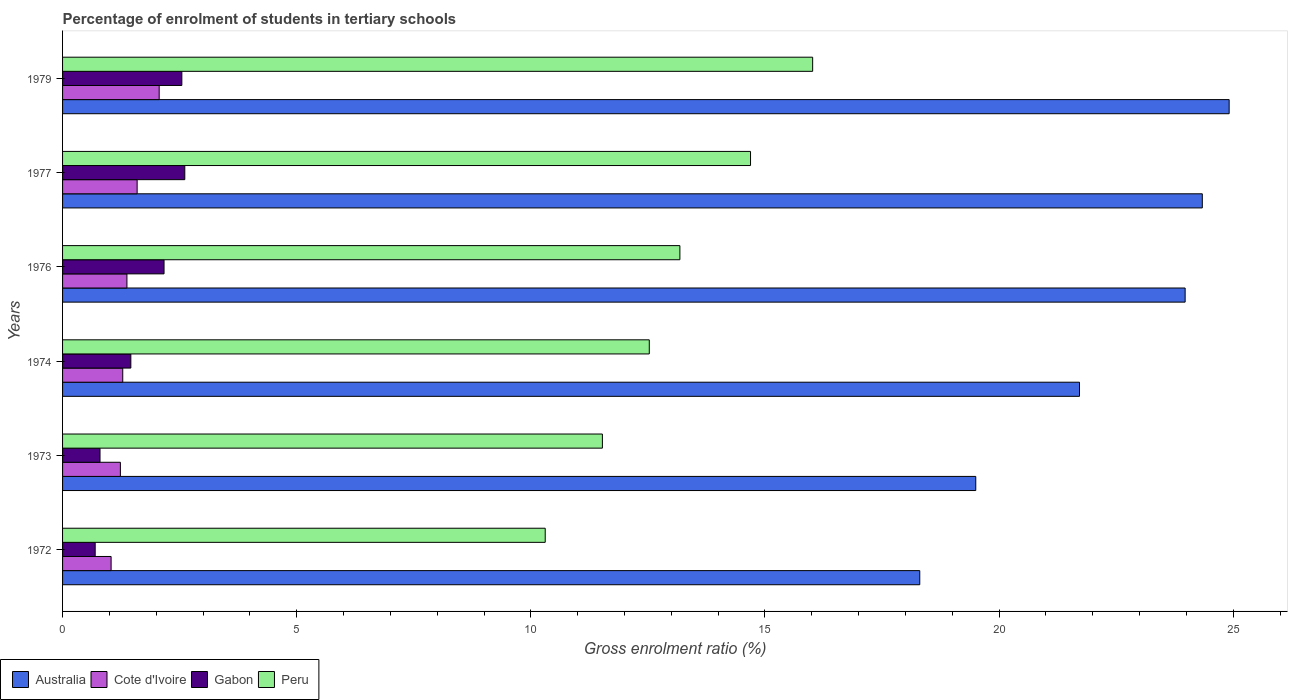How many different coloured bars are there?
Your answer should be very brief. 4. How many groups of bars are there?
Make the answer very short. 6. How many bars are there on the 6th tick from the bottom?
Your answer should be very brief. 4. What is the label of the 3rd group of bars from the top?
Your answer should be compact. 1976. What is the percentage of students enrolled in tertiary schools in Peru in 1972?
Offer a terse response. 10.31. Across all years, what is the maximum percentage of students enrolled in tertiary schools in Cote d'Ivoire?
Give a very brief answer. 2.06. Across all years, what is the minimum percentage of students enrolled in tertiary schools in Cote d'Ivoire?
Make the answer very short. 1.04. In which year was the percentage of students enrolled in tertiary schools in Cote d'Ivoire maximum?
Provide a short and direct response. 1979. What is the total percentage of students enrolled in tertiary schools in Cote d'Ivoire in the graph?
Provide a succinct answer. 8.59. What is the difference between the percentage of students enrolled in tertiary schools in Peru in 1974 and that in 1979?
Provide a succinct answer. -3.49. What is the difference between the percentage of students enrolled in tertiary schools in Australia in 1979 and the percentage of students enrolled in tertiary schools in Cote d'Ivoire in 1974?
Make the answer very short. 23.63. What is the average percentage of students enrolled in tertiary schools in Peru per year?
Your response must be concise. 13.04. In the year 1977, what is the difference between the percentage of students enrolled in tertiary schools in Australia and percentage of students enrolled in tertiary schools in Cote d'Ivoire?
Give a very brief answer. 22.75. In how many years, is the percentage of students enrolled in tertiary schools in Peru greater than 13 %?
Offer a terse response. 3. What is the ratio of the percentage of students enrolled in tertiary schools in Peru in 1973 to that in 1979?
Your answer should be compact. 0.72. What is the difference between the highest and the second highest percentage of students enrolled in tertiary schools in Peru?
Offer a terse response. 1.33. What is the difference between the highest and the lowest percentage of students enrolled in tertiary schools in Cote d'Ivoire?
Give a very brief answer. 1.03. In how many years, is the percentage of students enrolled in tertiary schools in Cote d'Ivoire greater than the average percentage of students enrolled in tertiary schools in Cote d'Ivoire taken over all years?
Your answer should be compact. 2. Is it the case that in every year, the sum of the percentage of students enrolled in tertiary schools in Cote d'Ivoire and percentage of students enrolled in tertiary schools in Australia is greater than the sum of percentage of students enrolled in tertiary schools in Gabon and percentage of students enrolled in tertiary schools in Peru?
Keep it short and to the point. Yes. What does the 2nd bar from the bottom in 1974 represents?
Your answer should be compact. Cote d'Ivoire. Is it the case that in every year, the sum of the percentage of students enrolled in tertiary schools in Australia and percentage of students enrolled in tertiary schools in Gabon is greater than the percentage of students enrolled in tertiary schools in Peru?
Your answer should be compact. Yes. How many bars are there?
Provide a succinct answer. 24. Are the values on the major ticks of X-axis written in scientific E-notation?
Provide a succinct answer. No. Does the graph contain any zero values?
Provide a short and direct response. No. Does the graph contain grids?
Your answer should be compact. No. How many legend labels are there?
Make the answer very short. 4. How are the legend labels stacked?
Your answer should be compact. Horizontal. What is the title of the graph?
Offer a very short reply. Percentage of enrolment of students in tertiary schools. What is the Gross enrolment ratio (%) in Australia in 1972?
Give a very brief answer. 18.31. What is the Gross enrolment ratio (%) in Cote d'Ivoire in 1972?
Make the answer very short. 1.04. What is the Gross enrolment ratio (%) of Gabon in 1972?
Offer a terse response. 0.7. What is the Gross enrolment ratio (%) in Peru in 1972?
Your answer should be very brief. 10.31. What is the Gross enrolment ratio (%) in Australia in 1973?
Give a very brief answer. 19.5. What is the Gross enrolment ratio (%) in Cote d'Ivoire in 1973?
Offer a very short reply. 1.23. What is the Gross enrolment ratio (%) of Gabon in 1973?
Make the answer very short. 0.8. What is the Gross enrolment ratio (%) of Peru in 1973?
Your response must be concise. 11.53. What is the Gross enrolment ratio (%) of Australia in 1974?
Ensure brevity in your answer.  21.72. What is the Gross enrolment ratio (%) of Cote d'Ivoire in 1974?
Offer a terse response. 1.29. What is the Gross enrolment ratio (%) of Gabon in 1974?
Ensure brevity in your answer.  1.46. What is the Gross enrolment ratio (%) in Peru in 1974?
Ensure brevity in your answer.  12.53. What is the Gross enrolment ratio (%) of Australia in 1976?
Offer a very short reply. 23.97. What is the Gross enrolment ratio (%) in Cote d'Ivoire in 1976?
Offer a very short reply. 1.37. What is the Gross enrolment ratio (%) in Gabon in 1976?
Your response must be concise. 2.17. What is the Gross enrolment ratio (%) in Peru in 1976?
Your answer should be very brief. 13.18. What is the Gross enrolment ratio (%) of Australia in 1977?
Provide a short and direct response. 24.34. What is the Gross enrolment ratio (%) in Cote d'Ivoire in 1977?
Keep it short and to the point. 1.59. What is the Gross enrolment ratio (%) in Gabon in 1977?
Provide a short and direct response. 2.61. What is the Gross enrolment ratio (%) of Peru in 1977?
Your response must be concise. 14.69. What is the Gross enrolment ratio (%) of Australia in 1979?
Keep it short and to the point. 24.91. What is the Gross enrolment ratio (%) in Cote d'Ivoire in 1979?
Provide a succinct answer. 2.06. What is the Gross enrolment ratio (%) in Gabon in 1979?
Provide a short and direct response. 2.55. What is the Gross enrolment ratio (%) of Peru in 1979?
Offer a terse response. 16.02. Across all years, what is the maximum Gross enrolment ratio (%) in Australia?
Provide a short and direct response. 24.91. Across all years, what is the maximum Gross enrolment ratio (%) of Cote d'Ivoire?
Your answer should be very brief. 2.06. Across all years, what is the maximum Gross enrolment ratio (%) of Gabon?
Provide a short and direct response. 2.61. Across all years, what is the maximum Gross enrolment ratio (%) of Peru?
Make the answer very short. 16.02. Across all years, what is the minimum Gross enrolment ratio (%) in Australia?
Your answer should be compact. 18.31. Across all years, what is the minimum Gross enrolment ratio (%) in Cote d'Ivoire?
Give a very brief answer. 1.04. Across all years, what is the minimum Gross enrolment ratio (%) of Gabon?
Your answer should be very brief. 0.7. Across all years, what is the minimum Gross enrolment ratio (%) in Peru?
Ensure brevity in your answer.  10.31. What is the total Gross enrolment ratio (%) of Australia in the graph?
Offer a terse response. 132.75. What is the total Gross enrolment ratio (%) in Cote d'Ivoire in the graph?
Keep it short and to the point. 8.59. What is the total Gross enrolment ratio (%) in Gabon in the graph?
Offer a terse response. 10.28. What is the total Gross enrolment ratio (%) in Peru in the graph?
Ensure brevity in your answer.  78.26. What is the difference between the Gross enrolment ratio (%) of Australia in 1972 and that in 1973?
Your response must be concise. -1.2. What is the difference between the Gross enrolment ratio (%) in Cote d'Ivoire in 1972 and that in 1973?
Ensure brevity in your answer.  -0.2. What is the difference between the Gross enrolment ratio (%) in Gabon in 1972 and that in 1973?
Your response must be concise. -0.1. What is the difference between the Gross enrolment ratio (%) in Peru in 1972 and that in 1973?
Keep it short and to the point. -1.22. What is the difference between the Gross enrolment ratio (%) in Australia in 1972 and that in 1974?
Provide a succinct answer. -3.41. What is the difference between the Gross enrolment ratio (%) in Cote d'Ivoire in 1972 and that in 1974?
Give a very brief answer. -0.25. What is the difference between the Gross enrolment ratio (%) of Gabon in 1972 and that in 1974?
Your response must be concise. -0.76. What is the difference between the Gross enrolment ratio (%) of Peru in 1972 and that in 1974?
Offer a terse response. -2.22. What is the difference between the Gross enrolment ratio (%) in Australia in 1972 and that in 1976?
Give a very brief answer. -5.67. What is the difference between the Gross enrolment ratio (%) of Cote d'Ivoire in 1972 and that in 1976?
Your response must be concise. -0.34. What is the difference between the Gross enrolment ratio (%) of Gabon in 1972 and that in 1976?
Your response must be concise. -1.47. What is the difference between the Gross enrolment ratio (%) in Peru in 1972 and that in 1976?
Your response must be concise. -2.88. What is the difference between the Gross enrolment ratio (%) of Australia in 1972 and that in 1977?
Your answer should be very brief. -6.03. What is the difference between the Gross enrolment ratio (%) in Cote d'Ivoire in 1972 and that in 1977?
Offer a very short reply. -0.56. What is the difference between the Gross enrolment ratio (%) of Gabon in 1972 and that in 1977?
Your answer should be very brief. -1.91. What is the difference between the Gross enrolment ratio (%) of Peru in 1972 and that in 1977?
Offer a very short reply. -4.38. What is the difference between the Gross enrolment ratio (%) of Australia in 1972 and that in 1979?
Keep it short and to the point. -6.61. What is the difference between the Gross enrolment ratio (%) of Cote d'Ivoire in 1972 and that in 1979?
Provide a short and direct response. -1.03. What is the difference between the Gross enrolment ratio (%) of Gabon in 1972 and that in 1979?
Offer a very short reply. -1.85. What is the difference between the Gross enrolment ratio (%) in Peru in 1972 and that in 1979?
Your response must be concise. -5.71. What is the difference between the Gross enrolment ratio (%) in Australia in 1973 and that in 1974?
Your answer should be very brief. -2.22. What is the difference between the Gross enrolment ratio (%) in Cote d'Ivoire in 1973 and that in 1974?
Your response must be concise. -0.05. What is the difference between the Gross enrolment ratio (%) in Gabon in 1973 and that in 1974?
Make the answer very short. -0.66. What is the difference between the Gross enrolment ratio (%) of Peru in 1973 and that in 1974?
Offer a terse response. -1. What is the difference between the Gross enrolment ratio (%) in Australia in 1973 and that in 1976?
Keep it short and to the point. -4.47. What is the difference between the Gross enrolment ratio (%) of Cote d'Ivoire in 1973 and that in 1976?
Give a very brief answer. -0.14. What is the difference between the Gross enrolment ratio (%) of Gabon in 1973 and that in 1976?
Your answer should be compact. -1.37. What is the difference between the Gross enrolment ratio (%) of Peru in 1973 and that in 1976?
Ensure brevity in your answer.  -1.66. What is the difference between the Gross enrolment ratio (%) of Australia in 1973 and that in 1977?
Your answer should be very brief. -4.84. What is the difference between the Gross enrolment ratio (%) in Cote d'Ivoire in 1973 and that in 1977?
Your answer should be very brief. -0.36. What is the difference between the Gross enrolment ratio (%) of Gabon in 1973 and that in 1977?
Your answer should be very brief. -1.81. What is the difference between the Gross enrolment ratio (%) in Peru in 1973 and that in 1977?
Offer a terse response. -3.16. What is the difference between the Gross enrolment ratio (%) of Australia in 1973 and that in 1979?
Your response must be concise. -5.41. What is the difference between the Gross enrolment ratio (%) in Cote d'Ivoire in 1973 and that in 1979?
Ensure brevity in your answer.  -0.83. What is the difference between the Gross enrolment ratio (%) of Gabon in 1973 and that in 1979?
Your answer should be compact. -1.75. What is the difference between the Gross enrolment ratio (%) of Peru in 1973 and that in 1979?
Keep it short and to the point. -4.49. What is the difference between the Gross enrolment ratio (%) in Australia in 1974 and that in 1976?
Provide a short and direct response. -2.26. What is the difference between the Gross enrolment ratio (%) in Cote d'Ivoire in 1974 and that in 1976?
Ensure brevity in your answer.  -0.09. What is the difference between the Gross enrolment ratio (%) in Gabon in 1974 and that in 1976?
Your answer should be very brief. -0.71. What is the difference between the Gross enrolment ratio (%) of Peru in 1974 and that in 1976?
Make the answer very short. -0.65. What is the difference between the Gross enrolment ratio (%) in Australia in 1974 and that in 1977?
Provide a short and direct response. -2.62. What is the difference between the Gross enrolment ratio (%) of Cote d'Ivoire in 1974 and that in 1977?
Your response must be concise. -0.31. What is the difference between the Gross enrolment ratio (%) of Gabon in 1974 and that in 1977?
Ensure brevity in your answer.  -1.15. What is the difference between the Gross enrolment ratio (%) in Peru in 1974 and that in 1977?
Your answer should be compact. -2.16. What is the difference between the Gross enrolment ratio (%) in Australia in 1974 and that in 1979?
Your response must be concise. -3.2. What is the difference between the Gross enrolment ratio (%) of Cote d'Ivoire in 1974 and that in 1979?
Provide a short and direct response. -0.78. What is the difference between the Gross enrolment ratio (%) of Gabon in 1974 and that in 1979?
Ensure brevity in your answer.  -1.09. What is the difference between the Gross enrolment ratio (%) in Peru in 1974 and that in 1979?
Offer a very short reply. -3.49. What is the difference between the Gross enrolment ratio (%) in Australia in 1976 and that in 1977?
Provide a short and direct response. -0.37. What is the difference between the Gross enrolment ratio (%) in Cote d'Ivoire in 1976 and that in 1977?
Your answer should be very brief. -0.22. What is the difference between the Gross enrolment ratio (%) of Gabon in 1976 and that in 1977?
Keep it short and to the point. -0.44. What is the difference between the Gross enrolment ratio (%) in Peru in 1976 and that in 1977?
Offer a terse response. -1.51. What is the difference between the Gross enrolment ratio (%) of Australia in 1976 and that in 1979?
Provide a short and direct response. -0.94. What is the difference between the Gross enrolment ratio (%) in Cote d'Ivoire in 1976 and that in 1979?
Offer a terse response. -0.69. What is the difference between the Gross enrolment ratio (%) of Gabon in 1976 and that in 1979?
Your answer should be very brief. -0.38. What is the difference between the Gross enrolment ratio (%) in Peru in 1976 and that in 1979?
Your response must be concise. -2.84. What is the difference between the Gross enrolment ratio (%) in Australia in 1977 and that in 1979?
Your answer should be compact. -0.57. What is the difference between the Gross enrolment ratio (%) of Cote d'Ivoire in 1977 and that in 1979?
Your answer should be compact. -0.47. What is the difference between the Gross enrolment ratio (%) in Gabon in 1977 and that in 1979?
Offer a very short reply. 0.06. What is the difference between the Gross enrolment ratio (%) of Peru in 1977 and that in 1979?
Provide a succinct answer. -1.33. What is the difference between the Gross enrolment ratio (%) of Australia in 1972 and the Gross enrolment ratio (%) of Cote d'Ivoire in 1973?
Provide a succinct answer. 17.07. What is the difference between the Gross enrolment ratio (%) of Australia in 1972 and the Gross enrolment ratio (%) of Gabon in 1973?
Make the answer very short. 17.51. What is the difference between the Gross enrolment ratio (%) of Australia in 1972 and the Gross enrolment ratio (%) of Peru in 1973?
Your answer should be very brief. 6.78. What is the difference between the Gross enrolment ratio (%) of Cote d'Ivoire in 1972 and the Gross enrolment ratio (%) of Gabon in 1973?
Offer a terse response. 0.24. What is the difference between the Gross enrolment ratio (%) in Cote d'Ivoire in 1972 and the Gross enrolment ratio (%) in Peru in 1973?
Your response must be concise. -10.49. What is the difference between the Gross enrolment ratio (%) of Gabon in 1972 and the Gross enrolment ratio (%) of Peru in 1973?
Provide a short and direct response. -10.83. What is the difference between the Gross enrolment ratio (%) in Australia in 1972 and the Gross enrolment ratio (%) in Cote d'Ivoire in 1974?
Provide a succinct answer. 17.02. What is the difference between the Gross enrolment ratio (%) of Australia in 1972 and the Gross enrolment ratio (%) of Gabon in 1974?
Make the answer very short. 16.85. What is the difference between the Gross enrolment ratio (%) of Australia in 1972 and the Gross enrolment ratio (%) of Peru in 1974?
Offer a terse response. 5.78. What is the difference between the Gross enrolment ratio (%) of Cote d'Ivoire in 1972 and the Gross enrolment ratio (%) of Gabon in 1974?
Provide a short and direct response. -0.42. What is the difference between the Gross enrolment ratio (%) in Cote d'Ivoire in 1972 and the Gross enrolment ratio (%) in Peru in 1974?
Offer a terse response. -11.49. What is the difference between the Gross enrolment ratio (%) of Gabon in 1972 and the Gross enrolment ratio (%) of Peru in 1974?
Your answer should be very brief. -11.83. What is the difference between the Gross enrolment ratio (%) of Australia in 1972 and the Gross enrolment ratio (%) of Cote d'Ivoire in 1976?
Give a very brief answer. 16.93. What is the difference between the Gross enrolment ratio (%) in Australia in 1972 and the Gross enrolment ratio (%) in Gabon in 1976?
Offer a terse response. 16.14. What is the difference between the Gross enrolment ratio (%) in Australia in 1972 and the Gross enrolment ratio (%) in Peru in 1976?
Provide a short and direct response. 5.12. What is the difference between the Gross enrolment ratio (%) in Cote d'Ivoire in 1972 and the Gross enrolment ratio (%) in Gabon in 1976?
Offer a terse response. -1.13. What is the difference between the Gross enrolment ratio (%) in Cote d'Ivoire in 1972 and the Gross enrolment ratio (%) in Peru in 1976?
Your answer should be compact. -12.15. What is the difference between the Gross enrolment ratio (%) in Gabon in 1972 and the Gross enrolment ratio (%) in Peru in 1976?
Ensure brevity in your answer.  -12.49. What is the difference between the Gross enrolment ratio (%) of Australia in 1972 and the Gross enrolment ratio (%) of Cote d'Ivoire in 1977?
Provide a succinct answer. 16.71. What is the difference between the Gross enrolment ratio (%) in Australia in 1972 and the Gross enrolment ratio (%) in Gabon in 1977?
Your answer should be compact. 15.7. What is the difference between the Gross enrolment ratio (%) in Australia in 1972 and the Gross enrolment ratio (%) in Peru in 1977?
Offer a terse response. 3.61. What is the difference between the Gross enrolment ratio (%) of Cote d'Ivoire in 1972 and the Gross enrolment ratio (%) of Gabon in 1977?
Offer a terse response. -1.57. What is the difference between the Gross enrolment ratio (%) of Cote d'Ivoire in 1972 and the Gross enrolment ratio (%) of Peru in 1977?
Provide a short and direct response. -13.66. What is the difference between the Gross enrolment ratio (%) in Gabon in 1972 and the Gross enrolment ratio (%) in Peru in 1977?
Your answer should be compact. -14. What is the difference between the Gross enrolment ratio (%) of Australia in 1972 and the Gross enrolment ratio (%) of Cote d'Ivoire in 1979?
Make the answer very short. 16.24. What is the difference between the Gross enrolment ratio (%) of Australia in 1972 and the Gross enrolment ratio (%) of Gabon in 1979?
Your answer should be very brief. 15.76. What is the difference between the Gross enrolment ratio (%) of Australia in 1972 and the Gross enrolment ratio (%) of Peru in 1979?
Offer a very short reply. 2.29. What is the difference between the Gross enrolment ratio (%) of Cote d'Ivoire in 1972 and the Gross enrolment ratio (%) of Gabon in 1979?
Ensure brevity in your answer.  -1.51. What is the difference between the Gross enrolment ratio (%) in Cote d'Ivoire in 1972 and the Gross enrolment ratio (%) in Peru in 1979?
Offer a very short reply. -14.98. What is the difference between the Gross enrolment ratio (%) in Gabon in 1972 and the Gross enrolment ratio (%) in Peru in 1979?
Ensure brevity in your answer.  -15.32. What is the difference between the Gross enrolment ratio (%) in Australia in 1973 and the Gross enrolment ratio (%) in Cote d'Ivoire in 1974?
Your answer should be very brief. 18.22. What is the difference between the Gross enrolment ratio (%) of Australia in 1973 and the Gross enrolment ratio (%) of Gabon in 1974?
Keep it short and to the point. 18.04. What is the difference between the Gross enrolment ratio (%) in Australia in 1973 and the Gross enrolment ratio (%) in Peru in 1974?
Give a very brief answer. 6.97. What is the difference between the Gross enrolment ratio (%) in Cote d'Ivoire in 1973 and the Gross enrolment ratio (%) in Gabon in 1974?
Offer a very short reply. -0.22. What is the difference between the Gross enrolment ratio (%) of Cote d'Ivoire in 1973 and the Gross enrolment ratio (%) of Peru in 1974?
Provide a short and direct response. -11.29. What is the difference between the Gross enrolment ratio (%) of Gabon in 1973 and the Gross enrolment ratio (%) of Peru in 1974?
Your response must be concise. -11.73. What is the difference between the Gross enrolment ratio (%) of Australia in 1973 and the Gross enrolment ratio (%) of Cote d'Ivoire in 1976?
Your response must be concise. 18.13. What is the difference between the Gross enrolment ratio (%) in Australia in 1973 and the Gross enrolment ratio (%) in Gabon in 1976?
Your answer should be very brief. 17.34. What is the difference between the Gross enrolment ratio (%) of Australia in 1973 and the Gross enrolment ratio (%) of Peru in 1976?
Offer a very short reply. 6.32. What is the difference between the Gross enrolment ratio (%) in Cote d'Ivoire in 1973 and the Gross enrolment ratio (%) in Gabon in 1976?
Your answer should be compact. -0.93. What is the difference between the Gross enrolment ratio (%) of Cote d'Ivoire in 1973 and the Gross enrolment ratio (%) of Peru in 1976?
Provide a short and direct response. -11.95. What is the difference between the Gross enrolment ratio (%) of Gabon in 1973 and the Gross enrolment ratio (%) of Peru in 1976?
Provide a succinct answer. -12.38. What is the difference between the Gross enrolment ratio (%) of Australia in 1973 and the Gross enrolment ratio (%) of Cote d'Ivoire in 1977?
Keep it short and to the point. 17.91. What is the difference between the Gross enrolment ratio (%) of Australia in 1973 and the Gross enrolment ratio (%) of Gabon in 1977?
Ensure brevity in your answer.  16.89. What is the difference between the Gross enrolment ratio (%) of Australia in 1973 and the Gross enrolment ratio (%) of Peru in 1977?
Keep it short and to the point. 4.81. What is the difference between the Gross enrolment ratio (%) of Cote d'Ivoire in 1973 and the Gross enrolment ratio (%) of Gabon in 1977?
Your answer should be compact. -1.38. What is the difference between the Gross enrolment ratio (%) of Cote d'Ivoire in 1973 and the Gross enrolment ratio (%) of Peru in 1977?
Offer a terse response. -13.46. What is the difference between the Gross enrolment ratio (%) of Gabon in 1973 and the Gross enrolment ratio (%) of Peru in 1977?
Give a very brief answer. -13.89. What is the difference between the Gross enrolment ratio (%) of Australia in 1973 and the Gross enrolment ratio (%) of Cote d'Ivoire in 1979?
Give a very brief answer. 17.44. What is the difference between the Gross enrolment ratio (%) of Australia in 1973 and the Gross enrolment ratio (%) of Gabon in 1979?
Provide a short and direct response. 16.95. What is the difference between the Gross enrolment ratio (%) of Australia in 1973 and the Gross enrolment ratio (%) of Peru in 1979?
Your answer should be compact. 3.48. What is the difference between the Gross enrolment ratio (%) in Cote d'Ivoire in 1973 and the Gross enrolment ratio (%) in Gabon in 1979?
Provide a short and direct response. -1.31. What is the difference between the Gross enrolment ratio (%) of Cote d'Ivoire in 1973 and the Gross enrolment ratio (%) of Peru in 1979?
Your answer should be compact. -14.78. What is the difference between the Gross enrolment ratio (%) in Gabon in 1973 and the Gross enrolment ratio (%) in Peru in 1979?
Your response must be concise. -15.22. What is the difference between the Gross enrolment ratio (%) of Australia in 1974 and the Gross enrolment ratio (%) of Cote d'Ivoire in 1976?
Your answer should be compact. 20.34. What is the difference between the Gross enrolment ratio (%) of Australia in 1974 and the Gross enrolment ratio (%) of Gabon in 1976?
Your answer should be compact. 19.55. What is the difference between the Gross enrolment ratio (%) of Australia in 1974 and the Gross enrolment ratio (%) of Peru in 1976?
Make the answer very short. 8.53. What is the difference between the Gross enrolment ratio (%) of Cote d'Ivoire in 1974 and the Gross enrolment ratio (%) of Gabon in 1976?
Ensure brevity in your answer.  -0.88. What is the difference between the Gross enrolment ratio (%) of Cote d'Ivoire in 1974 and the Gross enrolment ratio (%) of Peru in 1976?
Ensure brevity in your answer.  -11.9. What is the difference between the Gross enrolment ratio (%) in Gabon in 1974 and the Gross enrolment ratio (%) in Peru in 1976?
Provide a succinct answer. -11.73. What is the difference between the Gross enrolment ratio (%) in Australia in 1974 and the Gross enrolment ratio (%) in Cote d'Ivoire in 1977?
Ensure brevity in your answer.  20.12. What is the difference between the Gross enrolment ratio (%) in Australia in 1974 and the Gross enrolment ratio (%) in Gabon in 1977?
Your response must be concise. 19.11. What is the difference between the Gross enrolment ratio (%) of Australia in 1974 and the Gross enrolment ratio (%) of Peru in 1977?
Ensure brevity in your answer.  7.03. What is the difference between the Gross enrolment ratio (%) of Cote d'Ivoire in 1974 and the Gross enrolment ratio (%) of Gabon in 1977?
Offer a terse response. -1.33. What is the difference between the Gross enrolment ratio (%) in Cote d'Ivoire in 1974 and the Gross enrolment ratio (%) in Peru in 1977?
Provide a short and direct response. -13.41. What is the difference between the Gross enrolment ratio (%) in Gabon in 1974 and the Gross enrolment ratio (%) in Peru in 1977?
Ensure brevity in your answer.  -13.23. What is the difference between the Gross enrolment ratio (%) of Australia in 1974 and the Gross enrolment ratio (%) of Cote d'Ivoire in 1979?
Offer a very short reply. 19.65. What is the difference between the Gross enrolment ratio (%) in Australia in 1974 and the Gross enrolment ratio (%) in Gabon in 1979?
Ensure brevity in your answer.  19.17. What is the difference between the Gross enrolment ratio (%) in Australia in 1974 and the Gross enrolment ratio (%) in Peru in 1979?
Your response must be concise. 5.7. What is the difference between the Gross enrolment ratio (%) in Cote d'Ivoire in 1974 and the Gross enrolment ratio (%) in Gabon in 1979?
Provide a short and direct response. -1.26. What is the difference between the Gross enrolment ratio (%) of Cote d'Ivoire in 1974 and the Gross enrolment ratio (%) of Peru in 1979?
Provide a succinct answer. -14.73. What is the difference between the Gross enrolment ratio (%) in Gabon in 1974 and the Gross enrolment ratio (%) in Peru in 1979?
Provide a succinct answer. -14.56. What is the difference between the Gross enrolment ratio (%) in Australia in 1976 and the Gross enrolment ratio (%) in Cote d'Ivoire in 1977?
Your answer should be very brief. 22.38. What is the difference between the Gross enrolment ratio (%) in Australia in 1976 and the Gross enrolment ratio (%) in Gabon in 1977?
Give a very brief answer. 21.36. What is the difference between the Gross enrolment ratio (%) in Australia in 1976 and the Gross enrolment ratio (%) in Peru in 1977?
Provide a succinct answer. 9.28. What is the difference between the Gross enrolment ratio (%) of Cote d'Ivoire in 1976 and the Gross enrolment ratio (%) of Gabon in 1977?
Keep it short and to the point. -1.24. What is the difference between the Gross enrolment ratio (%) of Cote d'Ivoire in 1976 and the Gross enrolment ratio (%) of Peru in 1977?
Your response must be concise. -13.32. What is the difference between the Gross enrolment ratio (%) of Gabon in 1976 and the Gross enrolment ratio (%) of Peru in 1977?
Provide a succinct answer. -12.53. What is the difference between the Gross enrolment ratio (%) of Australia in 1976 and the Gross enrolment ratio (%) of Cote d'Ivoire in 1979?
Offer a very short reply. 21.91. What is the difference between the Gross enrolment ratio (%) of Australia in 1976 and the Gross enrolment ratio (%) of Gabon in 1979?
Your answer should be compact. 21.43. What is the difference between the Gross enrolment ratio (%) of Australia in 1976 and the Gross enrolment ratio (%) of Peru in 1979?
Your answer should be compact. 7.95. What is the difference between the Gross enrolment ratio (%) of Cote d'Ivoire in 1976 and the Gross enrolment ratio (%) of Gabon in 1979?
Your answer should be very brief. -1.17. What is the difference between the Gross enrolment ratio (%) of Cote d'Ivoire in 1976 and the Gross enrolment ratio (%) of Peru in 1979?
Ensure brevity in your answer.  -14.64. What is the difference between the Gross enrolment ratio (%) of Gabon in 1976 and the Gross enrolment ratio (%) of Peru in 1979?
Offer a terse response. -13.85. What is the difference between the Gross enrolment ratio (%) in Australia in 1977 and the Gross enrolment ratio (%) in Cote d'Ivoire in 1979?
Provide a short and direct response. 22.28. What is the difference between the Gross enrolment ratio (%) in Australia in 1977 and the Gross enrolment ratio (%) in Gabon in 1979?
Your response must be concise. 21.79. What is the difference between the Gross enrolment ratio (%) in Australia in 1977 and the Gross enrolment ratio (%) in Peru in 1979?
Make the answer very short. 8.32. What is the difference between the Gross enrolment ratio (%) in Cote d'Ivoire in 1977 and the Gross enrolment ratio (%) in Gabon in 1979?
Keep it short and to the point. -0.95. What is the difference between the Gross enrolment ratio (%) in Cote d'Ivoire in 1977 and the Gross enrolment ratio (%) in Peru in 1979?
Ensure brevity in your answer.  -14.43. What is the difference between the Gross enrolment ratio (%) in Gabon in 1977 and the Gross enrolment ratio (%) in Peru in 1979?
Keep it short and to the point. -13.41. What is the average Gross enrolment ratio (%) in Australia per year?
Your response must be concise. 22.13. What is the average Gross enrolment ratio (%) in Cote d'Ivoire per year?
Make the answer very short. 1.43. What is the average Gross enrolment ratio (%) of Gabon per year?
Offer a very short reply. 1.71. What is the average Gross enrolment ratio (%) of Peru per year?
Make the answer very short. 13.04. In the year 1972, what is the difference between the Gross enrolment ratio (%) of Australia and Gross enrolment ratio (%) of Cote d'Ivoire?
Your response must be concise. 17.27. In the year 1972, what is the difference between the Gross enrolment ratio (%) in Australia and Gross enrolment ratio (%) in Gabon?
Offer a very short reply. 17.61. In the year 1972, what is the difference between the Gross enrolment ratio (%) in Australia and Gross enrolment ratio (%) in Peru?
Make the answer very short. 8. In the year 1972, what is the difference between the Gross enrolment ratio (%) of Cote d'Ivoire and Gross enrolment ratio (%) of Gabon?
Your response must be concise. 0.34. In the year 1972, what is the difference between the Gross enrolment ratio (%) of Cote d'Ivoire and Gross enrolment ratio (%) of Peru?
Offer a terse response. -9.27. In the year 1972, what is the difference between the Gross enrolment ratio (%) in Gabon and Gross enrolment ratio (%) in Peru?
Provide a succinct answer. -9.61. In the year 1973, what is the difference between the Gross enrolment ratio (%) of Australia and Gross enrolment ratio (%) of Cote d'Ivoire?
Provide a short and direct response. 18.27. In the year 1973, what is the difference between the Gross enrolment ratio (%) of Australia and Gross enrolment ratio (%) of Gabon?
Give a very brief answer. 18.7. In the year 1973, what is the difference between the Gross enrolment ratio (%) in Australia and Gross enrolment ratio (%) in Peru?
Provide a succinct answer. 7.97. In the year 1973, what is the difference between the Gross enrolment ratio (%) of Cote d'Ivoire and Gross enrolment ratio (%) of Gabon?
Your answer should be compact. 0.43. In the year 1973, what is the difference between the Gross enrolment ratio (%) of Cote d'Ivoire and Gross enrolment ratio (%) of Peru?
Give a very brief answer. -10.29. In the year 1973, what is the difference between the Gross enrolment ratio (%) of Gabon and Gross enrolment ratio (%) of Peru?
Ensure brevity in your answer.  -10.73. In the year 1974, what is the difference between the Gross enrolment ratio (%) of Australia and Gross enrolment ratio (%) of Cote d'Ivoire?
Keep it short and to the point. 20.43. In the year 1974, what is the difference between the Gross enrolment ratio (%) in Australia and Gross enrolment ratio (%) in Gabon?
Provide a succinct answer. 20.26. In the year 1974, what is the difference between the Gross enrolment ratio (%) in Australia and Gross enrolment ratio (%) in Peru?
Keep it short and to the point. 9.19. In the year 1974, what is the difference between the Gross enrolment ratio (%) in Cote d'Ivoire and Gross enrolment ratio (%) in Gabon?
Your response must be concise. -0.17. In the year 1974, what is the difference between the Gross enrolment ratio (%) of Cote d'Ivoire and Gross enrolment ratio (%) of Peru?
Your answer should be compact. -11.24. In the year 1974, what is the difference between the Gross enrolment ratio (%) of Gabon and Gross enrolment ratio (%) of Peru?
Make the answer very short. -11.07. In the year 1976, what is the difference between the Gross enrolment ratio (%) of Australia and Gross enrolment ratio (%) of Cote d'Ivoire?
Offer a terse response. 22.6. In the year 1976, what is the difference between the Gross enrolment ratio (%) in Australia and Gross enrolment ratio (%) in Gabon?
Give a very brief answer. 21.81. In the year 1976, what is the difference between the Gross enrolment ratio (%) in Australia and Gross enrolment ratio (%) in Peru?
Your answer should be compact. 10.79. In the year 1976, what is the difference between the Gross enrolment ratio (%) in Cote d'Ivoire and Gross enrolment ratio (%) in Gabon?
Make the answer very short. -0.79. In the year 1976, what is the difference between the Gross enrolment ratio (%) of Cote d'Ivoire and Gross enrolment ratio (%) of Peru?
Your answer should be very brief. -11.81. In the year 1976, what is the difference between the Gross enrolment ratio (%) of Gabon and Gross enrolment ratio (%) of Peru?
Keep it short and to the point. -11.02. In the year 1977, what is the difference between the Gross enrolment ratio (%) in Australia and Gross enrolment ratio (%) in Cote d'Ivoire?
Your answer should be very brief. 22.75. In the year 1977, what is the difference between the Gross enrolment ratio (%) of Australia and Gross enrolment ratio (%) of Gabon?
Make the answer very short. 21.73. In the year 1977, what is the difference between the Gross enrolment ratio (%) in Australia and Gross enrolment ratio (%) in Peru?
Offer a very short reply. 9.65. In the year 1977, what is the difference between the Gross enrolment ratio (%) of Cote d'Ivoire and Gross enrolment ratio (%) of Gabon?
Provide a succinct answer. -1.02. In the year 1977, what is the difference between the Gross enrolment ratio (%) in Cote d'Ivoire and Gross enrolment ratio (%) in Peru?
Ensure brevity in your answer.  -13.1. In the year 1977, what is the difference between the Gross enrolment ratio (%) in Gabon and Gross enrolment ratio (%) in Peru?
Offer a very short reply. -12.08. In the year 1979, what is the difference between the Gross enrolment ratio (%) in Australia and Gross enrolment ratio (%) in Cote d'Ivoire?
Ensure brevity in your answer.  22.85. In the year 1979, what is the difference between the Gross enrolment ratio (%) of Australia and Gross enrolment ratio (%) of Gabon?
Your answer should be very brief. 22.37. In the year 1979, what is the difference between the Gross enrolment ratio (%) in Australia and Gross enrolment ratio (%) in Peru?
Provide a short and direct response. 8.89. In the year 1979, what is the difference between the Gross enrolment ratio (%) of Cote d'Ivoire and Gross enrolment ratio (%) of Gabon?
Make the answer very short. -0.48. In the year 1979, what is the difference between the Gross enrolment ratio (%) of Cote d'Ivoire and Gross enrolment ratio (%) of Peru?
Your answer should be compact. -13.96. In the year 1979, what is the difference between the Gross enrolment ratio (%) in Gabon and Gross enrolment ratio (%) in Peru?
Offer a very short reply. -13.47. What is the ratio of the Gross enrolment ratio (%) of Australia in 1972 to that in 1973?
Offer a very short reply. 0.94. What is the ratio of the Gross enrolment ratio (%) in Cote d'Ivoire in 1972 to that in 1973?
Your answer should be compact. 0.84. What is the ratio of the Gross enrolment ratio (%) in Gabon in 1972 to that in 1973?
Provide a short and direct response. 0.87. What is the ratio of the Gross enrolment ratio (%) of Peru in 1972 to that in 1973?
Your answer should be very brief. 0.89. What is the ratio of the Gross enrolment ratio (%) in Australia in 1972 to that in 1974?
Your answer should be compact. 0.84. What is the ratio of the Gross enrolment ratio (%) of Cote d'Ivoire in 1972 to that in 1974?
Provide a short and direct response. 0.81. What is the ratio of the Gross enrolment ratio (%) of Gabon in 1972 to that in 1974?
Your answer should be compact. 0.48. What is the ratio of the Gross enrolment ratio (%) of Peru in 1972 to that in 1974?
Give a very brief answer. 0.82. What is the ratio of the Gross enrolment ratio (%) of Australia in 1972 to that in 1976?
Offer a terse response. 0.76. What is the ratio of the Gross enrolment ratio (%) in Cote d'Ivoire in 1972 to that in 1976?
Give a very brief answer. 0.75. What is the ratio of the Gross enrolment ratio (%) of Gabon in 1972 to that in 1976?
Provide a short and direct response. 0.32. What is the ratio of the Gross enrolment ratio (%) in Peru in 1972 to that in 1976?
Give a very brief answer. 0.78. What is the ratio of the Gross enrolment ratio (%) of Australia in 1972 to that in 1977?
Give a very brief answer. 0.75. What is the ratio of the Gross enrolment ratio (%) in Cote d'Ivoire in 1972 to that in 1977?
Make the answer very short. 0.65. What is the ratio of the Gross enrolment ratio (%) of Gabon in 1972 to that in 1977?
Offer a very short reply. 0.27. What is the ratio of the Gross enrolment ratio (%) in Peru in 1972 to that in 1977?
Offer a very short reply. 0.7. What is the ratio of the Gross enrolment ratio (%) in Australia in 1972 to that in 1979?
Make the answer very short. 0.73. What is the ratio of the Gross enrolment ratio (%) in Cote d'Ivoire in 1972 to that in 1979?
Offer a very short reply. 0.5. What is the ratio of the Gross enrolment ratio (%) in Gabon in 1972 to that in 1979?
Provide a short and direct response. 0.27. What is the ratio of the Gross enrolment ratio (%) in Peru in 1972 to that in 1979?
Ensure brevity in your answer.  0.64. What is the ratio of the Gross enrolment ratio (%) in Australia in 1973 to that in 1974?
Offer a terse response. 0.9. What is the ratio of the Gross enrolment ratio (%) in Cote d'Ivoire in 1973 to that in 1974?
Keep it short and to the point. 0.96. What is the ratio of the Gross enrolment ratio (%) of Gabon in 1973 to that in 1974?
Offer a very short reply. 0.55. What is the ratio of the Gross enrolment ratio (%) in Peru in 1973 to that in 1974?
Ensure brevity in your answer.  0.92. What is the ratio of the Gross enrolment ratio (%) in Australia in 1973 to that in 1976?
Offer a very short reply. 0.81. What is the ratio of the Gross enrolment ratio (%) in Cote d'Ivoire in 1973 to that in 1976?
Keep it short and to the point. 0.9. What is the ratio of the Gross enrolment ratio (%) in Gabon in 1973 to that in 1976?
Your response must be concise. 0.37. What is the ratio of the Gross enrolment ratio (%) in Peru in 1973 to that in 1976?
Your answer should be very brief. 0.87. What is the ratio of the Gross enrolment ratio (%) in Australia in 1973 to that in 1977?
Make the answer very short. 0.8. What is the ratio of the Gross enrolment ratio (%) of Cote d'Ivoire in 1973 to that in 1977?
Your response must be concise. 0.78. What is the ratio of the Gross enrolment ratio (%) of Gabon in 1973 to that in 1977?
Offer a terse response. 0.31. What is the ratio of the Gross enrolment ratio (%) in Peru in 1973 to that in 1977?
Ensure brevity in your answer.  0.78. What is the ratio of the Gross enrolment ratio (%) of Australia in 1973 to that in 1979?
Your answer should be compact. 0.78. What is the ratio of the Gross enrolment ratio (%) in Cote d'Ivoire in 1973 to that in 1979?
Offer a terse response. 0.6. What is the ratio of the Gross enrolment ratio (%) in Gabon in 1973 to that in 1979?
Ensure brevity in your answer.  0.31. What is the ratio of the Gross enrolment ratio (%) of Peru in 1973 to that in 1979?
Make the answer very short. 0.72. What is the ratio of the Gross enrolment ratio (%) in Australia in 1974 to that in 1976?
Your answer should be very brief. 0.91. What is the ratio of the Gross enrolment ratio (%) in Cote d'Ivoire in 1974 to that in 1976?
Your response must be concise. 0.93. What is the ratio of the Gross enrolment ratio (%) of Gabon in 1974 to that in 1976?
Your response must be concise. 0.67. What is the ratio of the Gross enrolment ratio (%) of Peru in 1974 to that in 1976?
Your answer should be very brief. 0.95. What is the ratio of the Gross enrolment ratio (%) in Australia in 1974 to that in 1977?
Provide a short and direct response. 0.89. What is the ratio of the Gross enrolment ratio (%) of Cote d'Ivoire in 1974 to that in 1977?
Ensure brevity in your answer.  0.81. What is the ratio of the Gross enrolment ratio (%) of Gabon in 1974 to that in 1977?
Provide a short and direct response. 0.56. What is the ratio of the Gross enrolment ratio (%) in Peru in 1974 to that in 1977?
Make the answer very short. 0.85. What is the ratio of the Gross enrolment ratio (%) in Australia in 1974 to that in 1979?
Offer a very short reply. 0.87. What is the ratio of the Gross enrolment ratio (%) of Cote d'Ivoire in 1974 to that in 1979?
Provide a short and direct response. 0.62. What is the ratio of the Gross enrolment ratio (%) of Gabon in 1974 to that in 1979?
Keep it short and to the point. 0.57. What is the ratio of the Gross enrolment ratio (%) in Peru in 1974 to that in 1979?
Provide a short and direct response. 0.78. What is the ratio of the Gross enrolment ratio (%) in Australia in 1976 to that in 1977?
Make the answer very short. 0.98. What is the ratio of the Gross enrolment ratio (%) in Cote d'Ivoire in 1976 to that in 1977?
Offer a very short reply. 0.86. What is the ratio of the Gross enrolment ratio (%) in Gabon in 1976 to that in 1977?
Make the answer very short. 0.83. What is the ratio of the Gross enrolment ratio (%) of Peru in 1976 to that in 1977?
Your answer should be compact. 0.9. What is the ratio of the Gross enrolment ratio (%) in Australia in 1976 to that in 1979?
Provide a succinct answer. 0.96. What is the ratio of the Gross enrolment ratio (%) of Cote d'Ivoire in 1976 to that in 1979?
Offer a terse response. 0.67. What is the ratio of the Gross enrolment ratio (%) in Gabon in 1976 to that in 1979?
Provide a succinct answer. 0.85. What is the ratio of the Gross enrolment ratio (%) of Peru in 1976 to that in 1979?
Make the answer very short. 0.82. What is the ratio of the Gross enrolment ratio (%) in Australia in 1977 to that in 1979?
Make the answer very short. 0.98. What is the ratio of the Gross enrolment ratio (%) in Cote d'Ivoire in 1977 to that in 1979?
Ensure brevity in your answer.  0.77. What is the ratio of the Gross enrolment ratio (%) in Gabon in 1977 to that in 1979?
Ensure brevity in your answer.  1.02. What is the ratio of the Gross enrolment ratio (%) of Peru in 1977 to that in 1979?
Offer a terse response. 0.92. What is the difference between the highest and the second highest Gross enrolment ratio (%) in Australia?
Offer a very short reply. 0.57. What is the difference between the highest and the second highest Gross enrolment ratio (%) of Cote d'Ivoire?
Give a very brief answer. 0.47. What is the difference between the highest and the second highest Gross enrolment ratio (%) in Gabon?
Your answer should be very brief. 0.06. What is the difference between the highest and the second highest Gross enrolment ratio (%) of Peru?
Your answer should be compact. 1.33. What is the difference between the highest and the lowest Gross enrolment ratio (%) in Australia?
Make the answer very short. 6.61. What is the difference between the highest and the lowest Gross enrolment ratio (%) of Cote d'Ivoire?
Make the answer very short. 1.03. What is the difference between the highest and the lowest Gross enrolment ratio (%) of Gabon?
Offer a terse response. 1.91. What is the difference between the highest and the lowest Gross enrolment ratio (%) of Peru?
Make the answer very short. 5.71. 